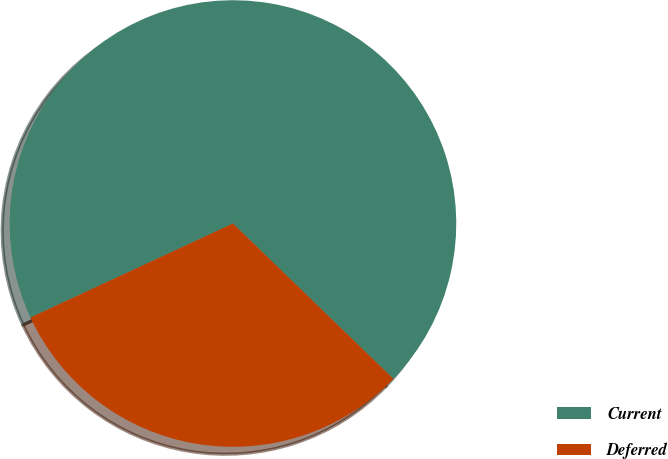Convert chart. <chart><loc_0><loc_0><loc_500><loc_500><pie_chart><fcel>Current<fcel>Deferred<nl><fcel>69.16%<fcel>30.84%<nl></chart> 